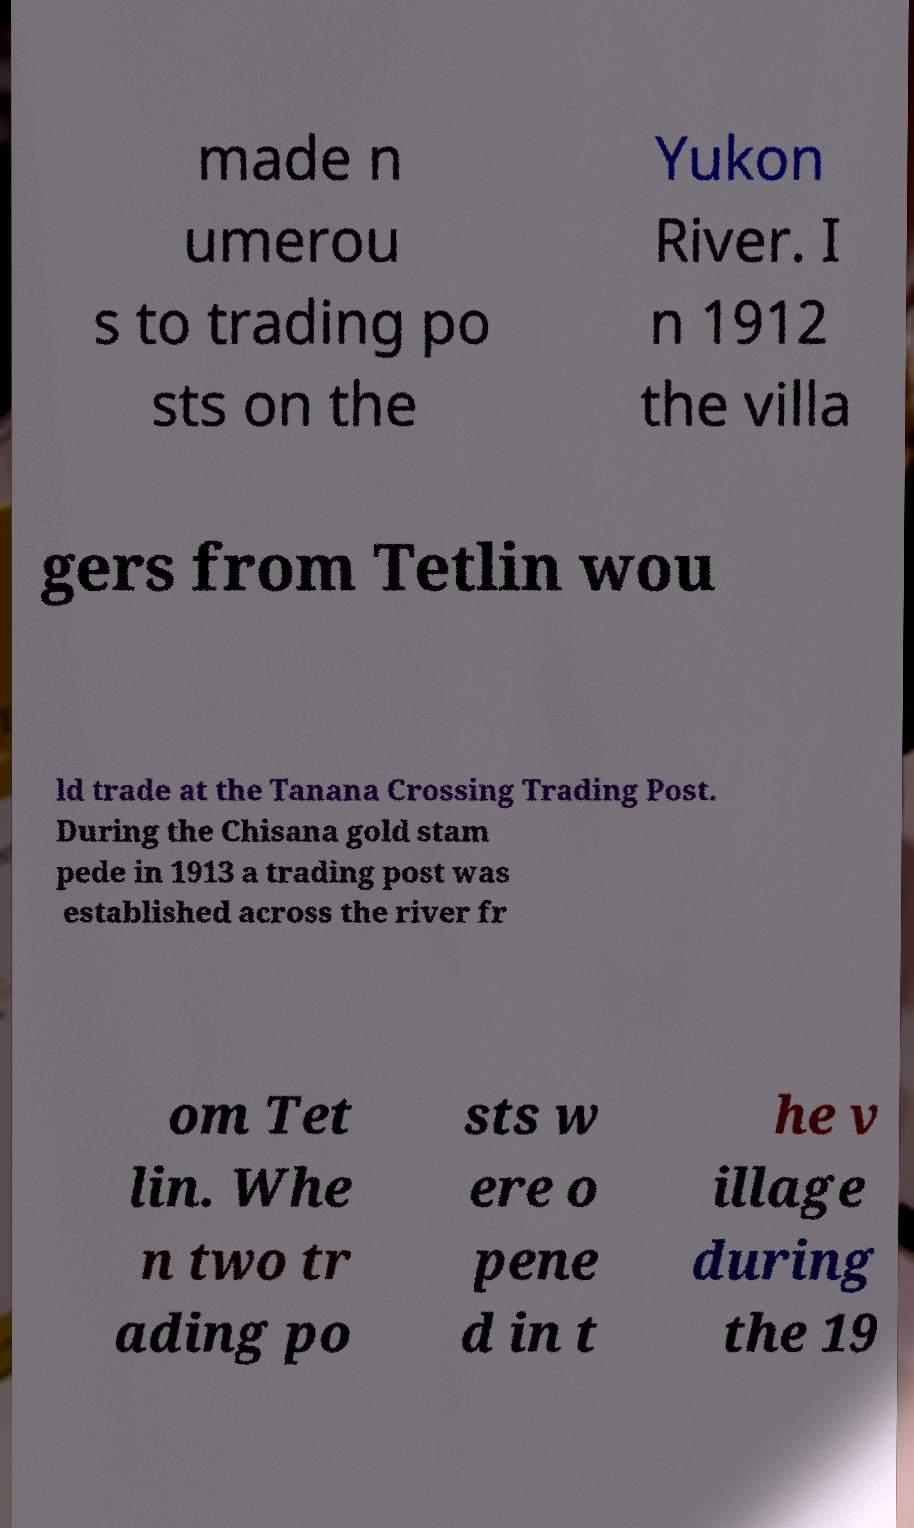There's text embedded in this image that I need extracted. Can you transcribe it verbatim? made n umerou s to trading po sts on the Yukon River. I n 1912 the villa gers from Tetlin wou ld trade at the Tanana Crossing Trading Post. During the Chisana gold stam pede in 1913 a trading post was established across the river fr om Tet lin. Whe n two tr ading po sts w ere o pene d in t he v illage during the 19 